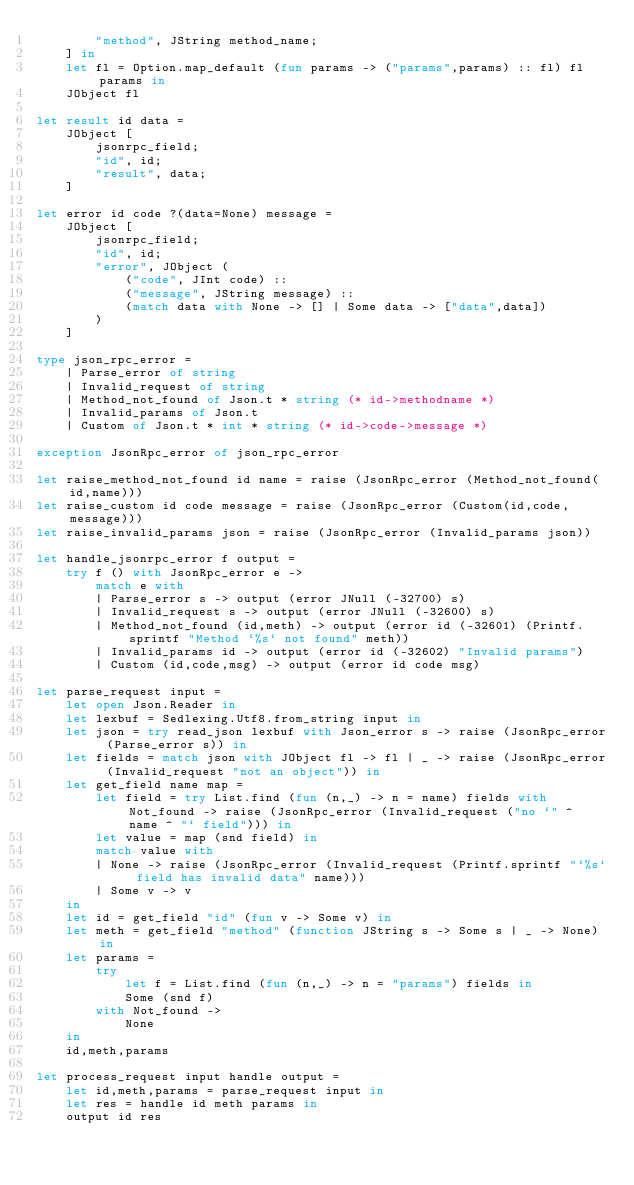Convert code to text. <code><loc_0><loc_0><loc_500><loc_500><_OCaml_>		"method", JString method_name;
	] in
	let fl = Option.map_default (fun params -> ("params",params) :: fl) fl params in
	JObject fl

let result id data =
	JObject [
		jsonrpc_field;
		"id", id;
		"result", data;
	]

let error id code ?(data=None) message =
	JObject [
		jsonrpc_field;
		"id", id;
		"error", JObject (
			("code", JInt code) ::
			("message", JString message) ::
			(match data with None -> [] | Some data -> ["data",data])
		)
	]

type json_rpc_error =
	| Parse_error of string
	| Invalid_request of string
	| Method_not_found of Json.t * string (* id->methodname *)
	| Invalid_params of Json.t
	| Custom of Json.t * int * string (* id->code->message *)

exception JsonRpc_error of json_rpc_error

let raise_method_not_found id name = raise (JsonRpc_error (Method_not_found(id,name)))
let raise_custom id code message = raise (JsonRpc_error (Custom(id,code,message)))
let raise_invalid_params json = raise (JsonRpc_error (Invalid_params json))

let handle_jsonrpc_error f output =
	try f () with JsonRpc_error e ->
		match e with
		| Parse_error s -> output (error JNull (-32700) s)
		| Invalid_request s -> output (error JNull (-32600) s)
		| Method_not_found (id,meth) -> output (error id (-32601) (Printf.sprintf "Method `%s` not found" meth))
		| Invalid_params id -> output (error id (-32602) "Invalid params")
		| Custom (id,code,msg) -> output (error id code msg)

let parse_request input =
	let open Json.Reader in
	let lexbuf = Sedlexing.Utf8.from_string input in
	let json = try read_json lexbuf with Json_error s -> raise (JsonRpc_error (Parse_error s)) in
	let fields = match json with JObject fl -> fl | _ -> raise (JsonRpc_error (Invalid_request "not an object")) in
	let get_field name map =
		let field = try List.find (fun (n,_) -> n = name) fields with Not_found -> raise (JsonRpc_error (Invalid_request ("no `" ^ name ^ "` field"))) in
		let value = map (snd field) in
		match value with
		| None -> raise (JsonRpc_error (Invalid_request (Printf.sprintf "`%s` field has invalid data" name)))
		| Some v -> v
	in
	let id = get_field "id" (fun v -> Some v) in
	let meth = get_field "method" (function JString s -> Some s | _ -> None) in
	let params =
		try
			let f = List.find (fun (n,_) -> n = "params") fields in
			Some (snd f)
		with Not_found ->
			None
	in
	id,meth,params

let process_request input handle output =
	let id,meth,params = parse_request input in
	let res = handle id meth params in
	output id res</code> 